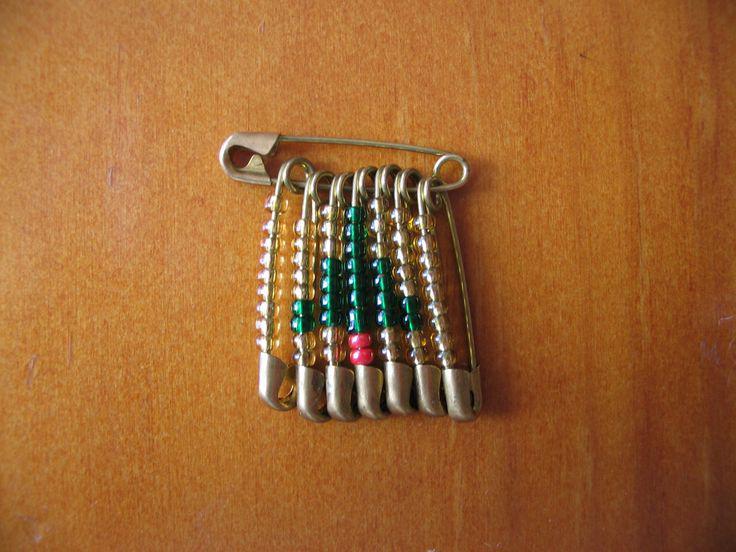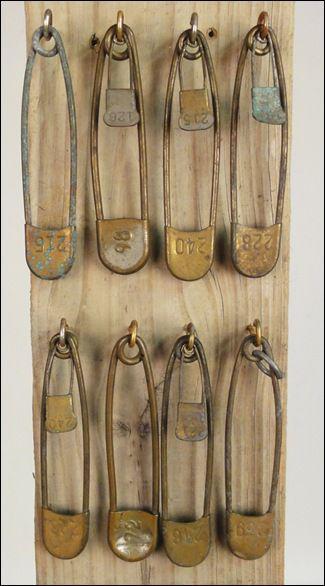The first image is the image on the left, the second image is the image on the right. Assess this claim about the two images: "There is one open safety pin.". Correct or not? Answer yes or no. No. The first image is the image on the left, the second image is the image on the right. For the images displayed, is the sentence "In one image a safety pin is open." factually correct? Answer yes or no. No. 